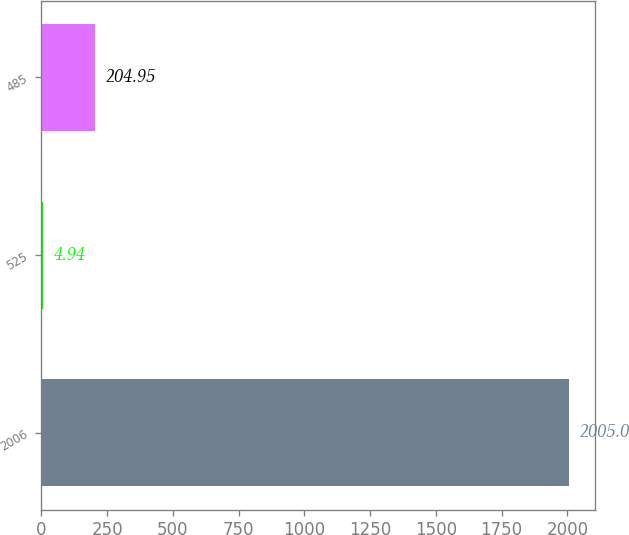Convert chart to OTSL. <chart><loc_0><loc_0><loc_500><loc_500><bar_chart><fcel>2006<fcel>525<fcel>485<nl><fcel>2005<fcel>4.94<fcel>204.95<nl></chart> 